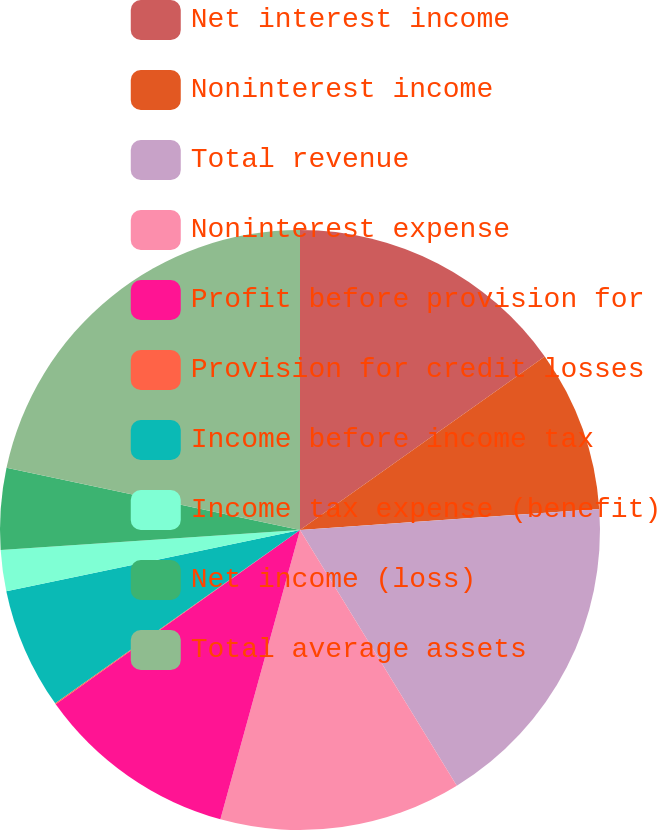Convert chart to OTSL. <chart><loc_0><loc_0><loc_500><loc_500><pie_chart><fcel>Net interest income<fcel>Noninterest income<fcel>Total revenue<fcel>Noninterest expense<fcel>Profit before provision for<fcel>Provision for credit losses<fcel>Income before income tax<fcel>Income tax expense (benefit)<fcel>Net income (loss)<fcel>Total average assets<nl><fcel>15.19%<fcel>8.7%<fcel>17.36%<fcel>13.03%<fcel>10.87%<fcel>0.05%<fcel>6.54%<fcel>2.21%<fcel>4.38%<fcel>21.68%<nl></chart> 